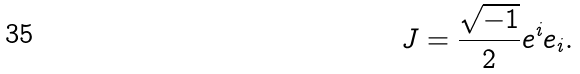<formula> <loc_0><loc_0><loc_500><loc_500>J = \frac { \sqrt { - 1 } } { 2 } e ^ { i } e _ { i } .</formula> 